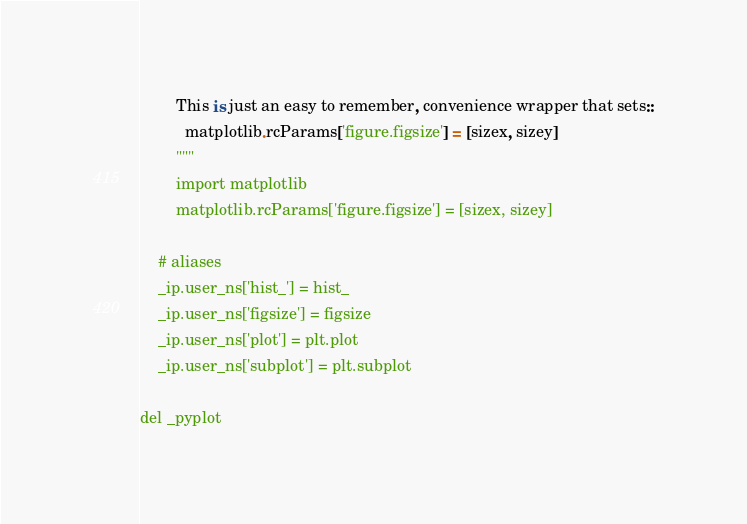<code> <loc_0><loc_0><loc_500><loc_500><_Python_>        This is just an easy to remember, convenience wrapper that sets::
          matplotlib.rcParams['figure.figsize'] = [sizex, sizey]
        """
        import matplotlib
        matplotlib.rcParams['figure.figsize'] = [sizex, sizey]

    # aliases
    _ip.user_ns['hist_'] = hist_
    _ip.user_ns['figsize'] = figsize
    _ip.user_ns['plot'] = plt.plot
    _ip.user_ns['subplot'] = plt.subplot

del _pyplot
</code> 